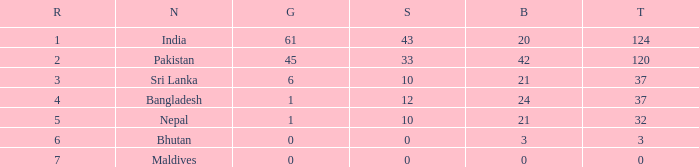Which Gold has a Nation of sri lanka, and a Silver smaller than 10? None. 